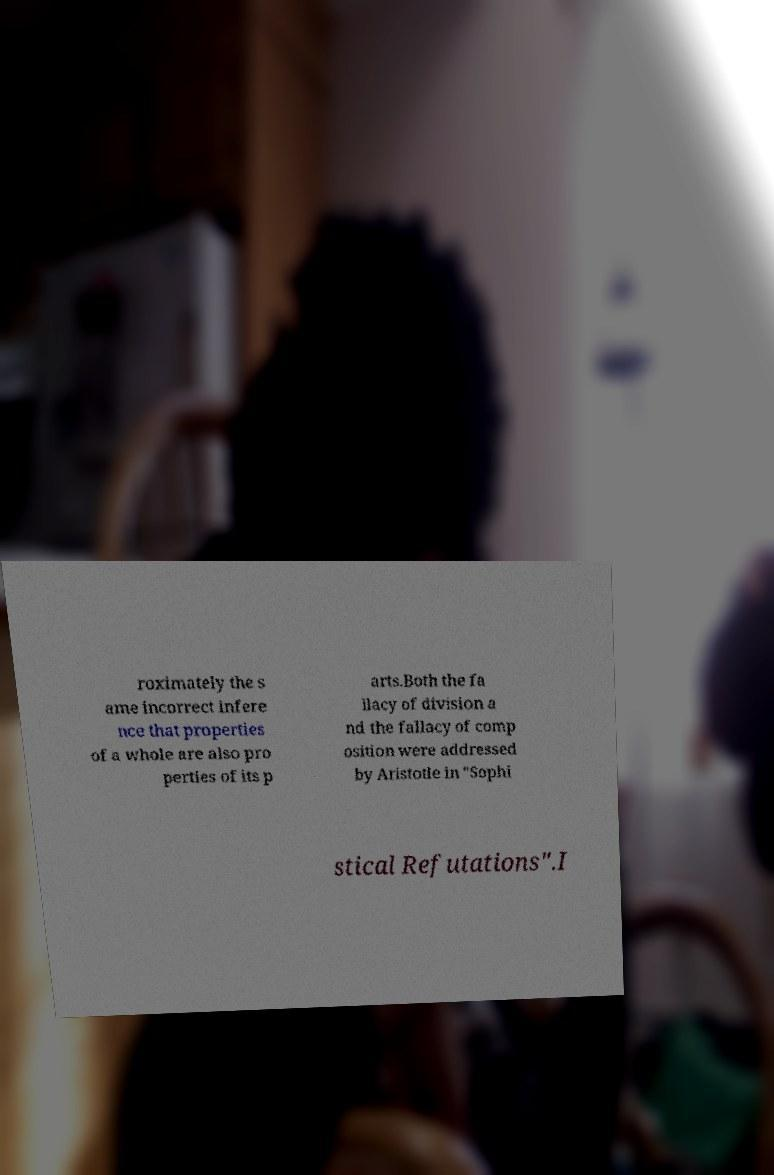Could you extract and type out the text from this image? roximately the s ame incorrect infere nce that properties of a whole are also pro perties of its p arts.Both the fa llacy of division a nd the fallacy of comp osition were addressed by Aristotle in "Sophi stical Refutations".I 